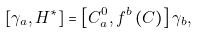<formula> <loc_0><loc_0><loc_500><loc_500>\left [ \gamma _ { a } , H ^ { * } \right ] = \left [ C _ { a } ^ { 0 } , f ^ { b } \left ( C \right ) \right ] \gamma _ { b } ,</formula> 